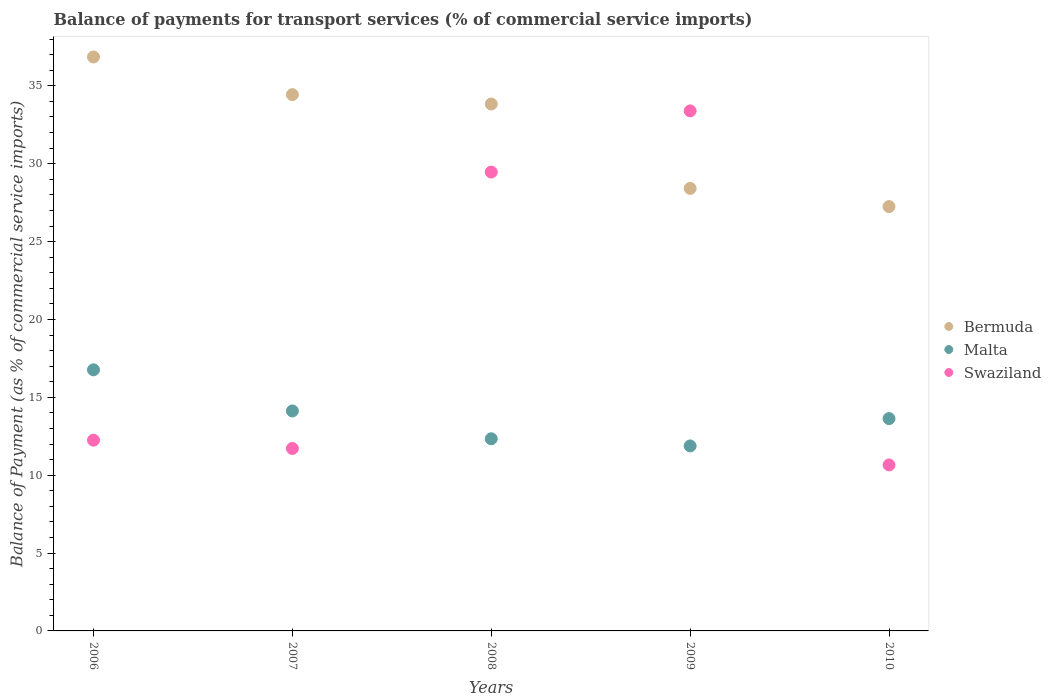How many different coloured dotlines are there?
Provide a short and direct response. 3. Is the number of dotlines equal to the number of legend labels?
Provide a short and direct response. Yes. What is the balance of payments for transport services in Malta in 2010?
Offer a very short reply. 13.63. Across all years, what is the maximum balance of payments for transport services in Malta?
Your answer should be compact. 16.77. Across all years, what is the minimum balance of payments for transport services in Malta?
Provide a succinct answer. 11.88. In which year was the balance of payments for transport services in Malta minimum?
Offer a very short reply. 2009. What is the total balance of payments for transport services in Malta in the graph?
Your response must be concise. 68.74. What is the difference between the balance of payments for transport services in Bermuda in 2007 and that in 2009?
Make the answer very short. 6.02. What is the difference between the balance of payments for transport services in Malta in 2006 and the balance of payments for transport services in Swaziland in 2010?
Offer a very short reply. 6.11. What is the average balance of payments for transport services in Swaziland per year?
Your answer should be compact. 19.5. In the year 2007, what is the difference between the balance of payments for transport services in Swaziland and balance of payments for transport services in Malta?
Make the answer very short. -2.41. What is the ratio of the balance of payments for transport services in Swaziland in 2006 to that in 2008?
Give a very brief answer. 0.42. What is the difference between the highest and the second highest balance of payments for transport services in Malta?
Your response must be concise. 2.64. What is the difference between the highest and the lowest balance of payments for transport services in Bermuda?
Give a very brief answer. 9.61. Is the sum of the balance of payments for transport services in Bermuda in 2007 and 2008 greater than the maximum balance of payments for transport services in Malta across all years?
Provide a succinct answer. Yes. Is it the case that in every year, the sum of the balance of payments for transport services in Malta and balance of payments for transport services in Swaziland  is greater than the balance of payments for transport services in Bermuda?
Offer a very short reply. No. Is the balance of payments for transport services in Malta strictly less than the balance of payments for transport services in Swaziland over the years?
Your answer should be compact. No. How many years are there in the graph?
Your answer should be compact. 5. Are the values on the major ticks of Y-axis written in scientific E-notation?
Provide a succinct answer. No. Where does the legend appear in the graph?
Offer a very short reply. Center right. What is the title of the graph?
Provide a short and direct response. Balance of payments for transport services (% of commercial service imports). What is the label or title of the X-axis?
Offer a terse response. Years. What is the label or title of the Y-axis?
Ensure brevity in your answer.  Balance of Payment (as % of commercial service imports). What is the Balance of Payment (as % of commercial service imports) of Bermuda in 2006?
Provide a short and direct response. 36.85. What is the Balance of Payment (as % of commercial service imports) in Malta in 2006?
Ensure brevity in your answer.  16.77. What is the Balance of Payment (as % of commercial service imports) in Swaziland in 2006?
Offer a terse response. 12.25. What is the Balance of Payment (as % of commercial service imports) in Bermuda in 2007?
Give a very brief answer. 34.44. What is the Balance of Payment (as % of commercial service imports) of Malta in 2007?
Make the answer very short. 14.12. What is the Balance of Payment (as % of commercial service imports) in Swaziland in 2007?
Offer a very short reply. 11.72. What is the Balance of Payment (as % of commercial service imports) of Bermuda in 2008?
Your answer should be very brief. 33.83. What is the Balance of Payment (as % of commercial service imports) of Malta in 2008?
Give a very brief answer. 12.34. What is the Balance of Payment (as % of commercial service imports) in Swaziland in 2008?
Offer a terse response. 29.46. What is the Balance of Payment (as % of commercial service imports) in Bermuda in 2009?
Make the answer very short. 28.41. What is the Balance of Payment (as % of commercial service imports) in Malta in 2009?
Your response must be concise. 11.88. What is the Balance of Payment (as % of commercial service imports) in Swaziland in 2009?
Ensure brevity in your answer.  33.39. What is the Balance of Payment (as % of commercial service imports) in Bermuda in 2010?
Offer a terse response. 27.25. What is the Balance of Payment (as % of commercial service imports) in Malta in 2010?
Ensure brevity in your answer.  13.63. What is the Balance of Payment (as % of commercial service imports) in Swaziland in 2010?
Make the answer very short. 10.66. Across all years, what is the maximum Balance of Payment (as % of commercial service imports) of Bermuda?
Give a very brief answer. 36.85. Across all years, what is the maximum Balance of Payment (as % of commercial service imports) in Malta?
Your response must be concise. 16.77. Across all years, what is the maximum Balance of Payment (as % of commercial service imports) of Swaziland?
Offer a terse response. 33.39. Across all years, what is the minimum Balance of Payment (as % of commercial service imports) in Bermuda?
Offer a very short reply. 27.25. Across all years, what is the minimum Balance of Payment (as % of commercial service imports) in Malta?
Your response must be concise. 11.88. Across all years, what is the minimum Balance of Payment (as % of commercial service imports) in Swaziland?
Your response must be concise. 10.66. What is the total Balance of Payment (as % of commercial service imports) in Bermuda in the graph?
Keep it short and to the point. 160.79. What is the total Balance of Payment (as % of commercial service imports) of Malta in the graph?
Offer a very short reply. 68.74. What is the total Balance of Payment (as % of commercial service imports) of Swaziland in the graph?
Provide a short and direct response. 97.48. What is the difference between the Balance of Payment (as % of commercial service imports) in Bermuda in 2006 and that in 2007?
Ensure brevity in your answer.  2.42. What is the difference between the Balance of Payment (as % of commercial service imports) in Malta in 2006 and that in 2007?
Your answer should be very brief. 2.64. What is the difference between the Balance of Payment (as % of commercial service imports) of Swaziland in 2006 and that in 2007?
Provide a succinct answer. 0.53. What is the difference between the Balance of Payment (as % of commercial service imports) in Bermuda in 2006 and that in 2008?
Provide a short and direct response. 3.02. What is the difference between the Balance of Payment (as % of commercial service imports) in Malta in 2006 and that in 2008?
Ensure brevity in your answer.  4.43. What is the difference between the Balance of Payment (as % of commercial service imports) of Swaziland in 2006 and that in 2008?
Provide a succinct answer. -17.22. What is the difference between the Balance of Payment (as % of commercial service imports) of Bermuda in 2006 and that in 2009?
Ensure brevity in your answer.  8.44. What is the difference between the Balance of Payment (as % of commercial service imports) of Malta in 2006 and that in 2009?
Your answer should be very brief. 4.89. What is the difference between the Balance of Payment (as % of commercial service imports) in Swaziland in 2006 and that in 2009?
Provide a succinct answer. -21.14. What is the difference between the Balance of Payment (as % of commercial service imports) of Bermuda in 2006 and that in 2010?
Provide a succinct answer. 9.61. What is the difference between the Balance of Payment (as % of commercial service imports) of Malta in 2006 and that in 2010?
Your answer should be very brief. 3.13. What is the difference between the Balance of Payment (as % of commercial service imports) of Swaziland in 2006 and that in 2010?
Offer a terse response. 1.59. What is the difference between the Balance of Payment (as % of commercial service imports) in Bermuda in 2007 and that in 2008?
Make the answer very short. 0.6. What is the difference between the Balance of Payment (as % of commercial service imports) in Malta in 2007 and that in 2008?
Your answer should be very brief. 1.79. What is the difference between the Balance of Payment (as % of commercial service imports) in Swaziland in 2007 and that in 2008?
Provide a succinct answer. -17.75. What is the difference between the Balance of Payment (as % of commercial service imports) in Bermuda in 2007 and that in 2009?
Keep it short and to the point. 6.02. What is the difference between the Balance of Payment (as % of commercial service imports) in Malta in 2007 and that in 2009?
Your response must be concise. 2.25. What is the difference between the Balance of Payment (as % of commercial service imports) of Swaziland in 2007 and that in 2009?
Your answer should be very brief. -21.68. What is the difference between the Balance of Payment (as % of commercial service imports) of Bermuda in 2007 and that in 2010?
Ensure brevity in your answer.  7.19. What is the difference between the Balance of Payment (as % of commercial service imports) of Malta in 2007 and that in 2010?
Provide a succinct answer. 0.49. What is the difference between the Balance of Payment (as % of commercial service imports) in Swaziland in 2007 and that in 2010?
Your answer should be very brief. 1.06. What is the difference between the Balance of Payment (as % of commercial service imports) in Bermuda in 2008 and that in 2009?
Provide a short and direct response. 5.42. What is the difference between the Balance of Payment (as % of commercial service imports) of Malta in 2008 and that in 2009?
Provide a short and direct response. 0.46. What is the difference between the Balance of Payment (as % of commercial service imports) in Swaziland in 2008 and that in 2009?
Your response must be concise. -3.93. What is the difference between the Balance of Payment (as % of commercial service imports) of Bermuda in 2008 and that in 2010?
Your answer should be compact. 6.58. What is the difference between the Balance of Payment (as % of commercial service imports) in Malta in 2008 and that in 2010?
Offer a terse response. -1.3. What is the difference between the Balance of Payment (as % of commercial service imports) in Swaziland in 2008 and that in 2010?
Provide a succinct answer. 18.81. What is the difference between the Balance of Payment (as % of commercial service imports) in Bermuda in 2009 and that in 2010?
Ensure brevity in your answer.  1.17. What is the difference between the Balance of Payment (as % of commercial service imports) of Malta in 2009 and that in 2010?
Offer a terse response. -1.76. What is the difference between the Balance of Payment (as % of commercial service imports) in Swaziland in 2009 and that in 2010?
Make the answer very short. 22.73. What is the difference between the Balance of Payment (as % of commercial service imports) in Bermuda in 2006 and the Balance of Payment (as % of commercial service imports) in Malta in 2007?
Ensure brevity in your answer.  22.73. What is the difference between the Balance of Payment (as % of commercial service imports) in Bermuda in 2006 and the Balance of Payment (as % of commercial service imports) in Swaziland in 2007?
Your answer should be compact. 25.14. What is the difference between the Balance of Payment (as % of commercial service imports) in Malta in 2006 and the Balance of Payment (as % of commercial service imports) in Swaziland in 2007?
Provide a succinct answer. 5.05. What is the difference between the Balance of Payment (as % of commercial service imports) in Bermuda in 2006 and the Balance of Payment (as % of commercial service imports) in Malta in 2008?
Your answer should be compact. 24.52. What is the difference between the Balance of Payment (as % of commercial service imports) in Bermuda in 2006 and the Balance of Payment (as % of commercial service imports) in Swaziland in 2008?
Ensure brevity in your answer.  7.39. What is the difference between the Balance of Payment (as % of commercial service imports) in Malta in 2006 and the Balance of Payment (as % of commercial service imports) in Swaziland in 2008?
Make the answer very short. -12.7. What is the difference between the Balance of Payment (as % of commercial service imports) of Bermuda in 2006 and the Balance of Payment (as % of commercial service imports) of Malta in 2009?
Offer a terse response. 24.98. What is the difference between the Balance of Payment (as % of commercial service imports) in Bermuda in 2006 and the Balance of Payment (as % of commercial service imports) in Swaziland in 2009?
Offer a terse response. 3.46. What is the difference between the Balance of Payment (as % of commercial service imports) in Malta in 2006 and the Balance of Payment (as % of commercial service imports) in Swaziland in 2009?
Provide a short and direct response. -16.63. What is the difference between the Balance of Payment (as % of commercial service imports) of Bermuda in 2006 and the Balance of Payment (as % of commercial service imports) of Malta in 2010?
Your response must be concise. 23.22. What is the difference between the Balance of Payment (as % of commercial service imports) in Bermuda in 2006 and the Balance of Payment (as % of commercial service imports) in Swaziland in 2010?
Make the answer very short. 26.2. What is the difference between the Balance of Payment (as % of commercial service imports) of Malta in 2006 and the Balance of Payment (as % of commercial service imports) of Swaziland in 2010?
Ensure brevity in your answer.  6.11. What is the difference between the Balance of Payment (as % of commercial service imports) of Bermuda in 2007 and the Balance of Payment (as % of commercial service imports) of Malta in 2008?
Give a very brief answer. 22.1. What is the difference between the Balance of Payment (as % of commercial service imports) in Bermuda in 2007 and the Balance of Payment (as % of commercial service imports) in Swaziland in 2008?
Give a very brief answer. 4.97. What is the difference between the Balance of Payment (as % of commercial service imports) in Malta in 2007 and the Balance of Payment (as % of commercial service imports) in Swaziland in 2008?
Provide a succinct answer. -15.34. What is the difference between the Balance of Payment (as % of commercial service imports) of Bermuda in 2007 and the Balance of Payment (as % of commercial service imports) of Malta in 2009?
Provide a succinct answer. 22.56. What is the difference between the Balance of Payment (as % of commercial service imports) of Bermuda in 2007 and the Balance of Payment (as % of commercial service imports) of Swaziland in 2009?
Provide a short and direct response. 1.04. What is the difference between the Balance of Payment (as % of commercial service imports) of Malta in 2007 and the Balance of Payment (as % of commercial service imports) of Swaziland in 2009?
Give a very brief answer. -19.27. What is the difference between the Balance of Payment (as % of commercial service imports) in Bermuda in 2007 and the Balance of Payment (as % of commercial service imports) in Malta in 2010?
Provide a succinct answer. 20.8. What is the difference between the Balance of Payment (as % of commercial service imports) in Bermuda in 2007 and the Balance of Payment (as % of commercial service imports) in Swaziland in 2010?
Keep it short and to the point. 23.78. What is the difference between the Balance of Payment (as % of commercial service imports) in Malta in 2007 and the Balance of Payment (as % of commercial service imports) in Swaziland in 2010?
Your answer should be compact. 3.47. What is the difference between the Balance of Payment (as % of commercial service imports) in Bermuda in 2008 and the Balance of Payment (as % of commercial service imports) in Malta in 2009?
Provide a succinct answer. 21.96. What is the difference between the Balance of Payment (as % of commercial service imports) in Bermuda in 2008 and the Balance of Payment (as % of commercial service imports) in Swaziland in 2009?
Your response must be concise. 0.44. What is the difference between the Balance of Payment (as % of commercial service imports) in Malta in 2008 and the Balance of Payment (as % of commercial service imports) in Swaziland in 2009?
Ensure brevity in your answer.  -21.05. What is the difference between the Balance of Payment (as % of commercial service imports) of Bermuda in 2008 and the Balance of Payment (as % of commercial service imports) of Malta in 2010?
Make the answer very short. 20.2. What is the difference between the Balance of Payment (as % of commercial service imports) of Bermuda in 2008 and the Balance of Payment (as % of commercial service imports) of Swaziland in 2010?
Keep it short and to the point. 23.18. What is the difference between the Balance of Payment (as % of commercial service imports) in Malta in 2008 and the Balance of Payment (as % of commercial service imports) in Swaziland in 2010?
Provide a succinct answer. 1.68. What is the difference between the Balance of Payment (as % of commercial service imports) in Bermuda in 2009 and the Balance of Payment (as % of commercial service imports) in Malta in 2010?
Your answer should be compact. 14.78. What is the difference between the Balance of Payment (as % of commercial service imports) of Bermuda in 2009 and the Balance of Payment (as % of commercial service imports) of Swaziland in 2010?
Give a very brief answer. 17.76. What is the difference between the Balance of Payment (as % of commercial service imports) in Malta in 2009 and the Balance of Payment (as % of commercial service imports) in Swaziland in 2010?
Provide a succinct answer. 1.22. What is the average Balance of Payment (as % of commercial service imports) of Bermuda per year?
Your response must be concise. 32.16. What is the average Balance of Payment (as % of commercial service imports) in Malta per year?
Your answer should be very brief. 13.75. What is the average Balance of Payment (as % of commercial service imports) in Swaziland per year?
Your answer should be compact. 19.5. In the year 2006, what is the difference between the Balance of Payment (as % of commercial service imports) in Bermuda and Balance of Payment (as % of commercial service imports) in Malta?
Provide a short and direct response. 20.09. In the year 2006, what is the difference between the Balance of Payment (as % of commercial service imports) in Bermuda and Balance of Payment (as % of commercial service imports) in Swaziland?
Your response must be concise. 24.61. In the year 2006, what is the difference between the Balance of Payment (as % of commercial service imports) of Malta and Balance of Payment (as % of commercial service imports) of Swaziland?
Provide a short and direct response. 4.52. In the year 2007, what is the difference between the Balance of Payment (as % of commercial service imports) in Bermuda and Balance of Payment (as % of commercial service imports) in Malta?
Offer a very short reply. 20.31. In the year 2007, what is the difference between the Balance of Payment (as % of commercial service imports) of Bermuda and Balance of Payment (as % of commercial service imports) of Swaziland?
Your response must be concise. 22.72. In the year 2007, what is the difference between the Balance of Payment (as % of commercial service imports) of Malta and Balance of Payment (as % of commercial service imports) of Swaziland?
Keep it short and to the point. 2.41. In the year 2008, what is the difference between the Balance of Payment (as % of commercial service imports) in Bermuda and Balance of Payment (as % of commercial service imports) in Malta?
Provide a short and direct response. 21.5. In the year 2008, what is the difference between the Balance of Payment (as % of commercial service imports) in Bermuda and Balance of Payment (as % of commercial service imports) in Swaziland?
Provide a short and direct response. 4.37. In the year 2008, what is the difference between the Balance of Payment (as % of commercial service imports) in Malta and Balance of Payment (as % of commercial service imports) in Swaziland?
Keep it short and to the point. -17.13. In the year 2009, what is the difference between the Balance of Payment (as % of commercial service imports) of Bermuda and Balance of Payment (as % of commercial service imports) of Malta?
Offer a terse response. 16.54. In the year 2009, what is the difference between the Balance of Payment (as % of commercial service imports) of Bermuda and Balance of Payment (as % of commercial service imports) of Swaziland?
Make the answer very short. -4.98. In the year 2009, what is the difference between the Balance of Payment (as % of commercial service imports) of Malta and Balance of Payment (as % of commercial service imports) of Swaziland?
Your answer should be very brief. -21.51. In the year 2010, what is the difference between the Balance of Payment (as % of commercial service imports) of Bermuda and Balance of Payment (as % of commercial service imports) of Malta?
Offer a very short reply. 13.61. In the year 2010, what is the difference between the Balance of Payment (as % of commercial service imports) of Bermuda and Balance of Payment (as % of commercial service imports) of Swaziland?
Provide a succinct answer. 16.59. In the year 2010, what is the difference between the Balance of Payment (as % of commercial service imports) in Malta and Balance of Payment (as % of commercial service imports) in Swaziland?
Your answer should be very brief. 2.98. What is the ratio of the Balance of Payment (as % of commercial service imports) of Bermuda in 2006 to that in 2007?
Your answer should be very brief. 1.07. What is the ratio of the Balance of Payment (as % of commercial service imports) in Malta in 2006 to that in 2007?
Offer a very short reply. 1.19. What is the ratio of the Balance of Payment (as % of commercial service imports) of Swaziland in 2006 to that in 2007?
Your answer should be compact. 1.05. What is the ratio of the Balance of Payment (as % of commercial service imports) of Bermuda in 2006 to that in 2008?
Give a very brief answer. 1.09. What is the ratio of the Balance of Payment (as % of commercial service imports) in Malta in 2006 to that in 2008?
Your answer should be compact. 1.36. What is the ratio of the Balance of Payment (as % of commercial service imports) in Swaziland in 2006 to that in 2008?
Ensure brevity in your answer.  0.42. What is the ratio of the Balance of Payment (as % of commercial service imports) of Bermuda in 2006 to that in 2009?
Your response must be concise. 1.3. What is the ratio of the Balance of Payment (as % of commercial service imports) of Malta in 2006 to that in 2009?
Offer a very short reply. 1.41. What is the ratio of the Balance of Payment (as % of commercial service imports) in Swaziland in 2006 to that in 2009?
Your response must be concise. 0.37. What is the ratio of the Balance of Payment (as % of commercial service imports) in Bermuda in 2006 to that in 2010?
Provide a succinct answer. 1.35. What is the ratio of the Balance of Payment (as % of commercial service imports) in Malta in 2006 to that in 2010?
Make the answer very short. 1.23. What is the ratio of the Balance of Payment (as % of commercial service imports) of Swaziland in 2006 to that in 2010?
Offer a terse response. 1.15. What is the ratio of the Balance of Payment (as % of commercial service imports) of Bermuda in 2007 to that in 2008?
Your answer should be very brief. 1.02. What is the ratio of the Balance of Payment (as % of commercial service imports) in Malta in 2007 to that in 2008?
Keep it short and to the point. 1.14. What is the ratio of the Balance of Payment (as % of commercial service imports) in Swaziland in 2007 to that in 2008?
Offer a terse response. 0.4. What is the ratio of the Balance of Payment (as % of commercial service imports) of Bermuda in 2007 to that in 2009?
Provide a short and direct response. 1.21. What is the ratio of the Balance of Payment (as % of commercial service imports) in Malta in 2007 to that in 2009?
Your response must be concise. 1.19. What is the ratio of the Balance of Payment (as % of commercial service imports) of Swaziland in 2007 to that in 2009?
Provide a short and direct response. 0.35. What is the ratio of the Balance of Payment (as % of commercial service imports) in Bermuda in 2007 to that in 2010?
Offer a very short reply. 1.26. What is the ratio of the Balance of Payment (as % of commercial service imports) in Malta in 2007 to that in 2010?
Ensure brevity in your answer.  1.04. What is the ratio of the Balance of Payment (as % of commercial service imports) of Swaziland in 2007 to that in 2010?
Offer a terse response. 1.1. What is the ratio of the Balance of Payment (as % of commercial service imports) in Bermuda in 2008 to that in 2009?
Give a very brief answer. 1.19. What is the ratio of the Balance of Payment (as % of commercial service imports) of Malta in 2008 to that in 2009?
Provide a short and direct response. 1.04. What is the ratio of the Balance of Payment (as % of commercial service imports) in Swaziland in 2008 to that in 2009?
Offer a very short reply. 0.88. What is the ratio of the Balance of Payment (as % of commercial service imports) in Bermuda in 2008 to that in 2010?
Your response must be concise. 1.24. What is the ratio of the Balance of Payment (as % of commercial service imports) of Malta in 2008 to that in 2010?
Keep it short and to the point. 0.9. What is the ratio of the Balance of Payment (as % of commercial service imports) of Swaziland in 2008 to that in 2010?
Give a very brief answer. 2.76. What is the ratio of the Balance of Payment (as % of commercial service imports) of Bermuda in 2009 to that in 2010?
Your response must be concise. 1.04. What is the ratio of the Balance of Payment (as % of commercial service imports) in Malta in 2009 to that in 2010?
Keep it short and to the point. 0.87. What is the ratio of the Balance of Payment (as % of commercial service imports) of Swaziland in 2009 to that in 2010?
Provide a succinct answer. 3.13. What is the difference between the highest and the second highest Balance of Payment (as % of commercial service imports) in Bermuda?
Your response must be concise. 2.42. What is the difference between the highest and the second highest Balance of Payment (as % of commercial service imports) in Malta?
Make the answer very short. 2.64. What is the difference between the highest and the second highest Balance of Payment (as % of commercial service imports) in Swaziland?
Provide a short and direct response. 3.93. What is the difference between the highest and the lowest Balance of Payment (as % of commercial service imports) in Bermuda?
Your response must be concise. 9.61. What is the difference between the highest and the lowest Balance of Payment (as % of commercial service imports) of Malta?
Give a very brief answer. 4.89. What is the difference between the highest and the lowest Balance of Payment (as % of commercial service imports) in Swaziland?
Your answer should be very brief. 22.73. 